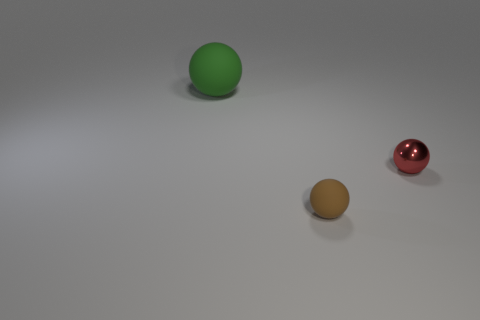Add 3 large green objects. How many objects exist? 6 Add 1 small red metallic spheres. How many small red metallic spheres are left? 2 Add 3 big purple metal cubes. How many big purple metal cubes exist? 3 Subtract 0 brown cylinders. How many objects are left? 3 Subtract all small objects. Subtract all big red metallic cubes. How many objects are left? 1 